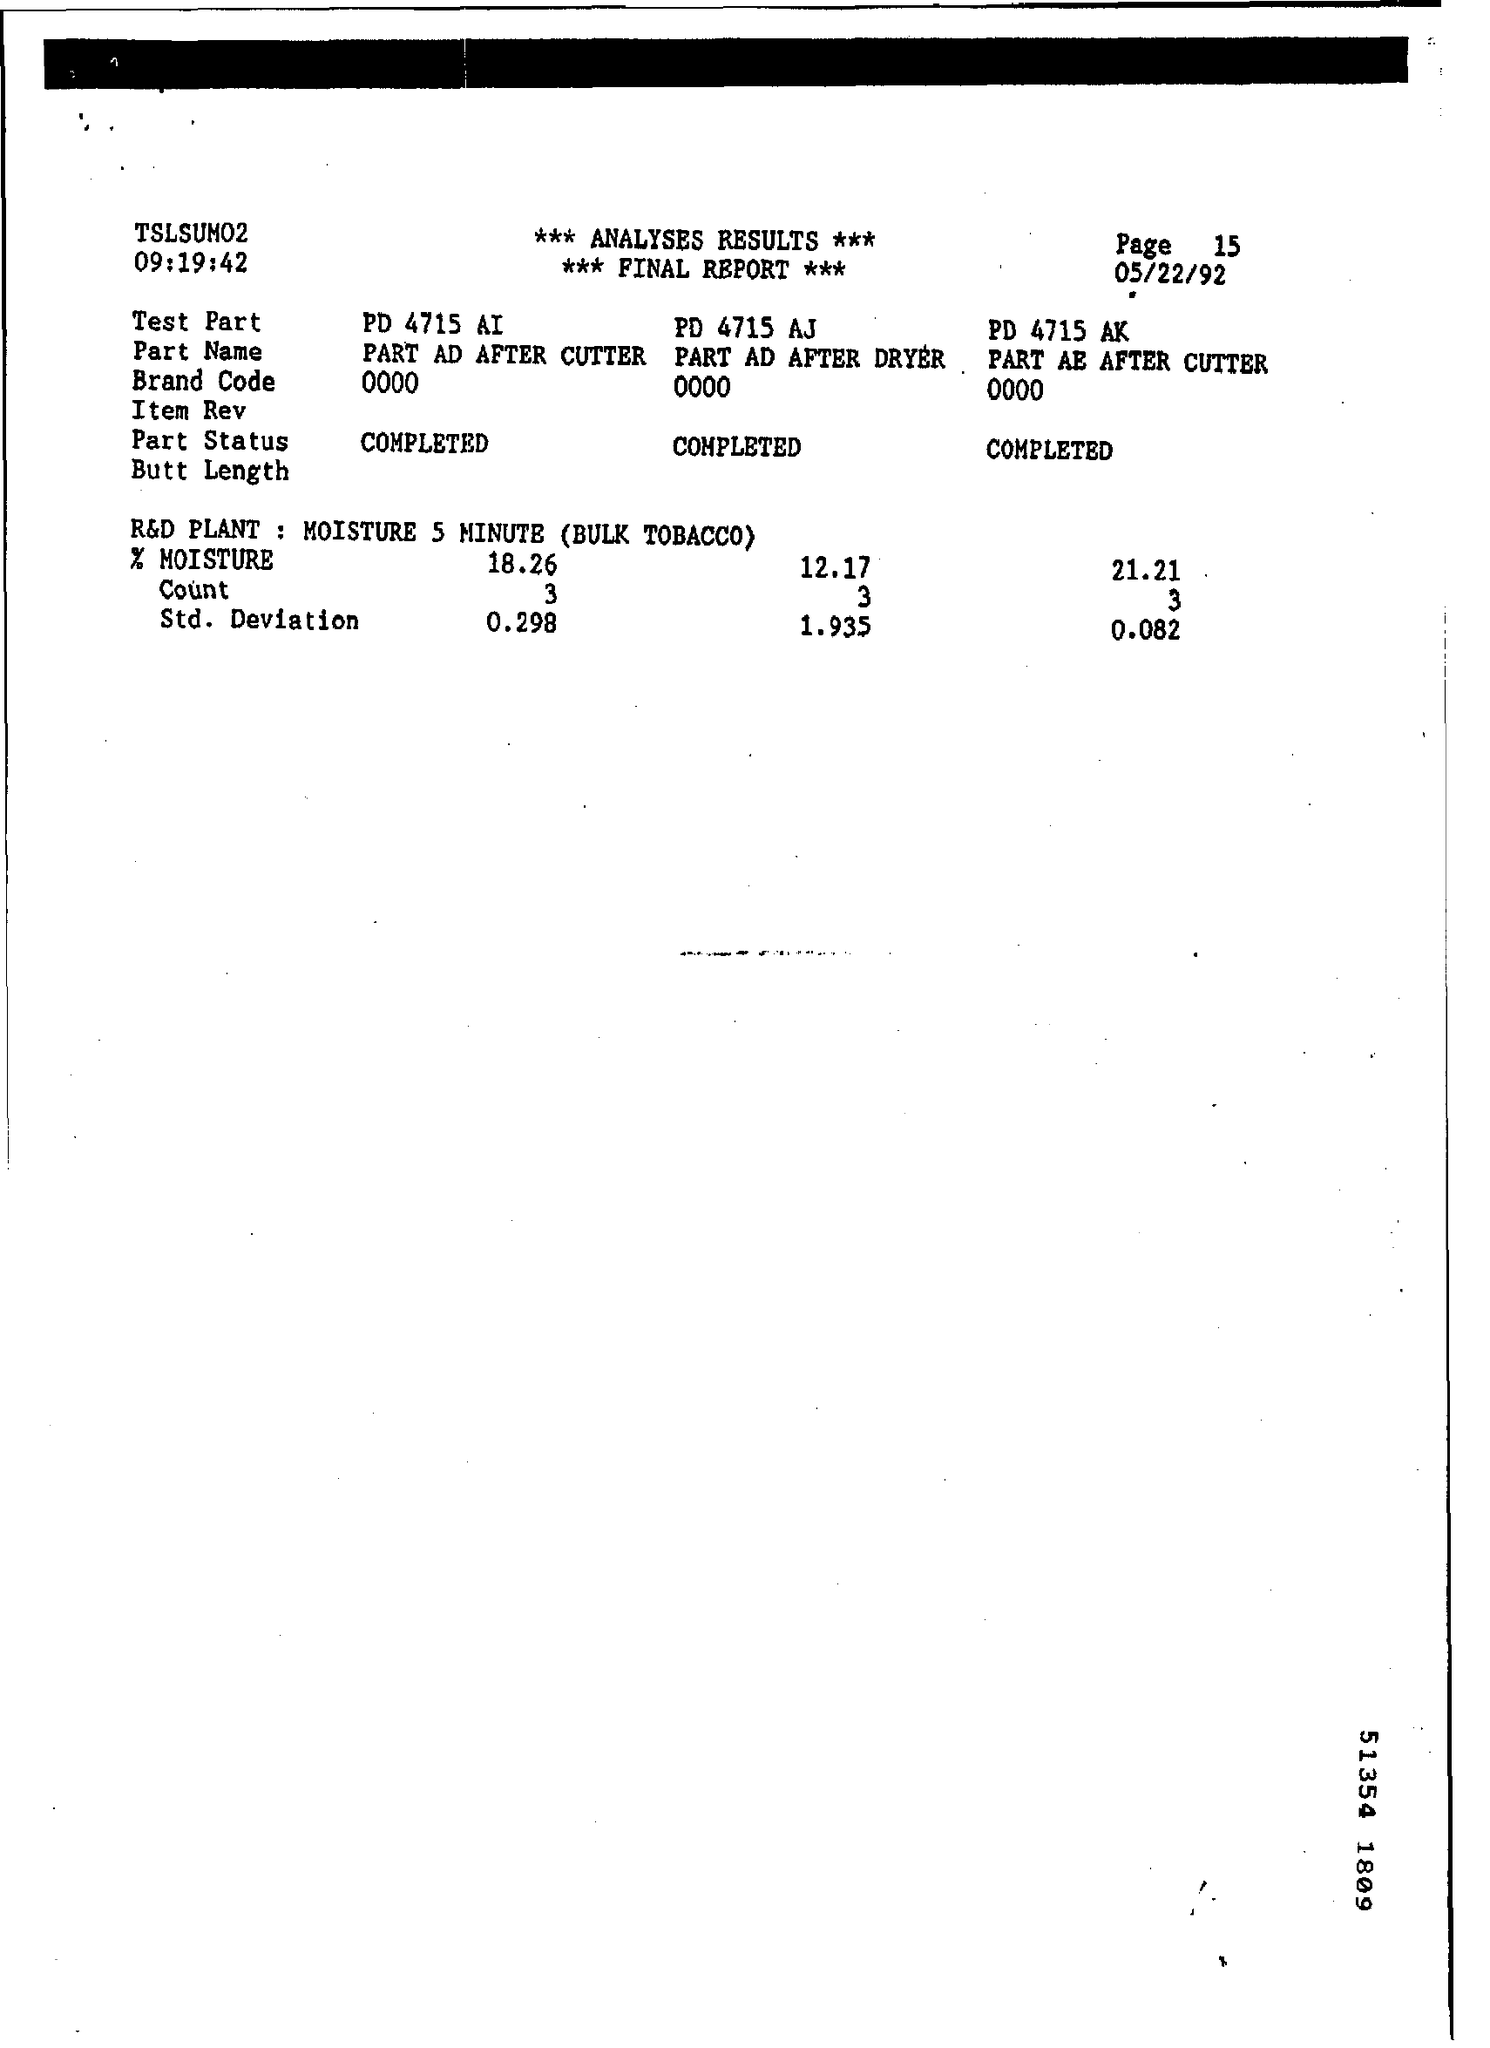Identify some key points in this picture. What is the test part for PART AE AFTER CUTTER? PD 4715 AK..." is a question asking what the purpose or function of a specific test part is, specified by PART AE AFTER CUTTER and PD 4715 AK. The analysis is complete. The standard deviation of PD 4715 AJ is 1.935. 